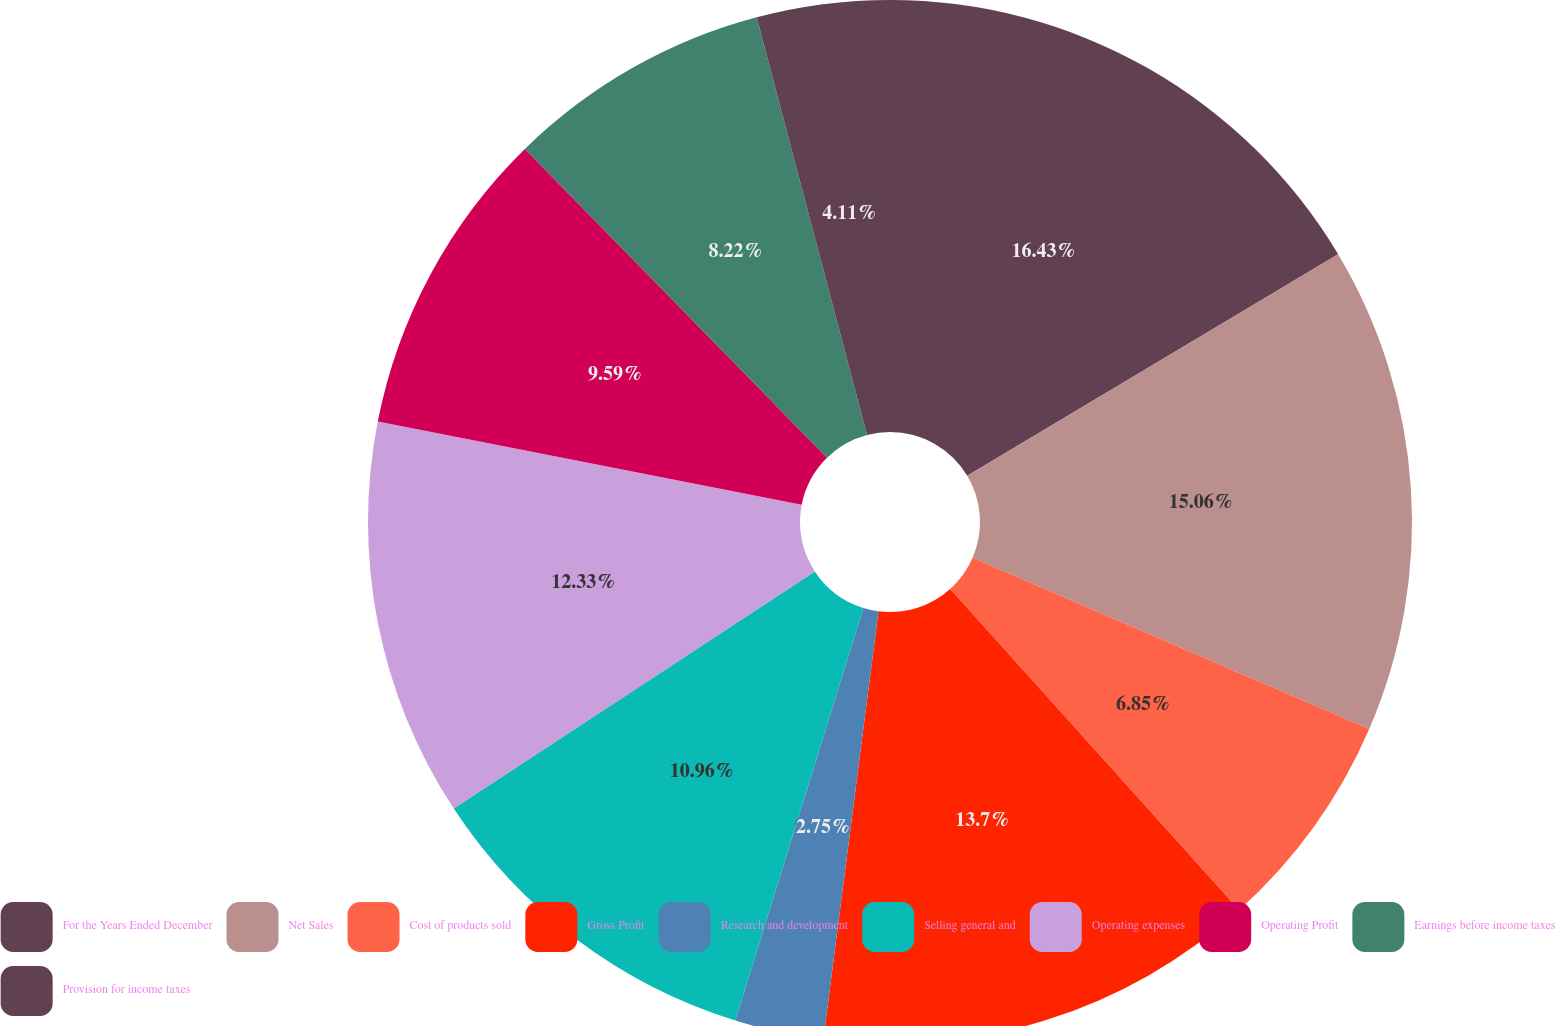Convert chart. <chart><loc_0><loc_0><loc_500><loc_500><pie_chart><fcel>For the Years Ended December<fcel>Net Sales<fcel>Cost of products sold<fcel>Gross Profit<fcel>Research and development<fcel>Selling general and<fcel>Operating expenses<fcel>Operating Profit<fcel>Earnings before income taxes<fcel>Provision for income taxes<nl><fcel>16.43%<fcel>15.06%<fcel>6.85%<fcel>13.7%<fcel>2.75%<fcel>10.96%<fcel>12.33%<fcel>9.59%<fcel>8.22%<fcel>4.11%<nl></chart> 